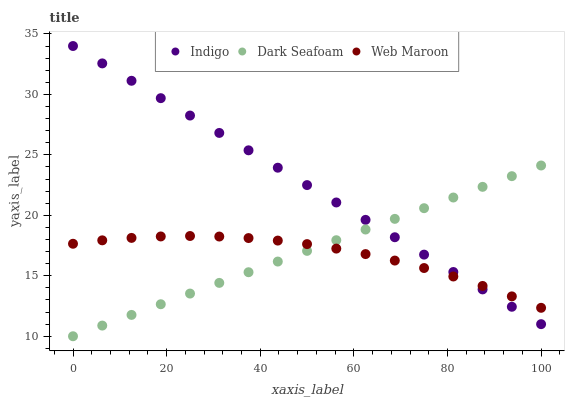Does Web Maroon have the minimum area under the curve?
Answer yes or no. Yes. Does Indigo have the maximum area under the curve?
Answer yes or no. Yes. Does Dark Seafoam have the minimum area under the curve?
Answer yes or no. No. Does Dark Seafoam have the maximum area under the curve?
Answer yes or no. No. Is Dark Seafoam the smoothest?
Answer yes or no. Yes. Is Web Maroon the roughest?
Answer yes or no. Yes. Is Indigo the smoothest?
Answer yes or no. No. Is Indigo the roughest?
Answer yes or no. No. Does Dark Seafoam have the lowest value?
Answer yes or no. Yes. Does Indigo have the lowest value?
Answer yes or no. No. Does Indigo have the highest value?
Answer yes or no. Yes. Does Dark Seafoam have the highest value?
Answer yes or no. No. Does Dark Seafoam intersect Indigo?
Answer yes or no. Yes. Is Dark Seafoam less than Indigo?
Answer yes or no. No. Is Dark Seafoam greater than Indigo?
Answer yes or no. No. 